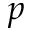Convert formula to latex. <formula><loc_0><loc_0><loc_500><loc_500>p</formula> 